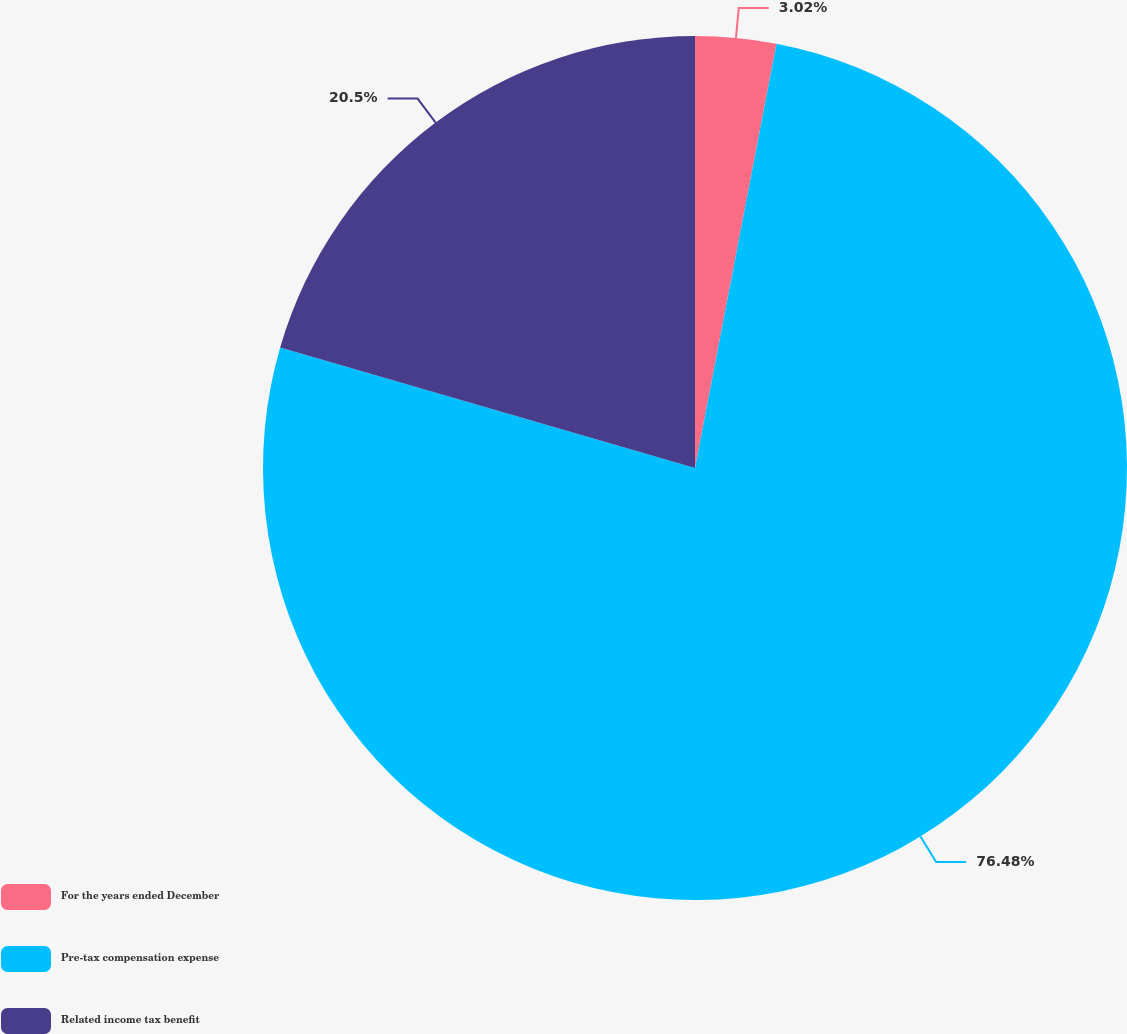<chart> <loc_0><loc_0><loc_500><loc_500><pie_chart><fcel>For the years ended December<fcel>Pre-tax compensation expense<fcel>Related income tax benefit<nl><fcel>3.02%<fcel>76.48%<fcel>20.5%<nl></chart> 